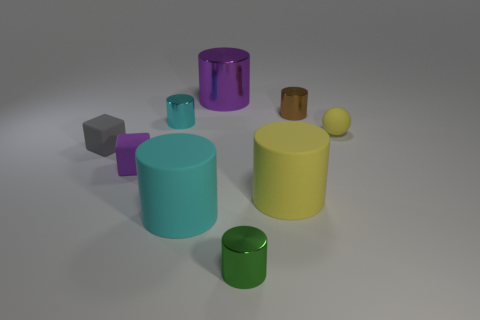Subtract all yellow cylinders. How many cylinders are left? 5 Subtract 3 cylinders. How many cylinders are left? 3 Subtract all yellow rubber cylinders. How many cylinders are left? 5 Subtract all red cubes. Subtract all red balls. How many cubes are left? 2 Add 1 big cyan balls. How many objects exist? 10 Subtract all spheres. How many objects are left? 8 Add 8 small rubber cubes. How many small rubber cubes are left? 10 Add 3 tiny red shiny blocks. How many tiny red shiny blocks exist? 3 Subtract 1 purple cylinders. How many objects are left? 8 Subtract all tiny cyan shiny cylinders. Subtract all tiny purple matte objects. How many objects are left? 7 